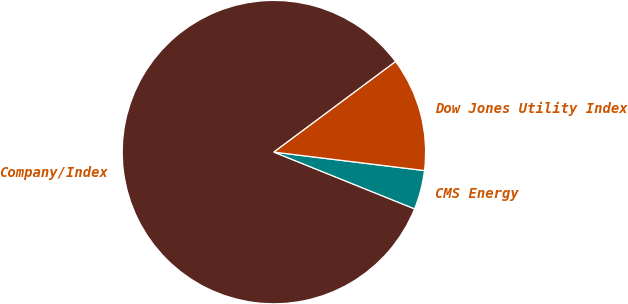Convert chart. <chart><loc_0><loc_0><loc_500><loc_500><pie_chart><fcel>Company/Index<fcel>CMS Energy<fcel>Dow Jones Utility Index<nl><fcel>83.72%<fcel>4.16%<fcel>12.12%<nl></chart> 